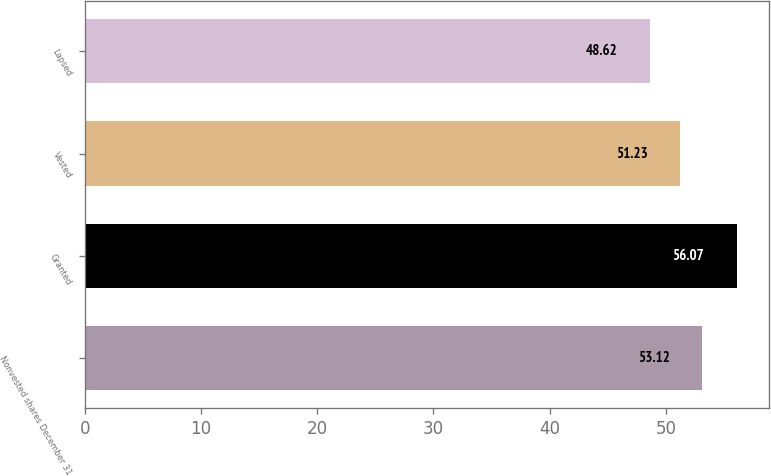<chart> <loc_0><loc_0><loc_500><loc_500><bar_chart><fcel>Nonvested shares December 31<fcel>Granted<fcel>Vested<fcel>Lapsed<nl><fcel>53.12<fcel>56.07<fcel>51.23<fcel>48.62<nl></chart> 